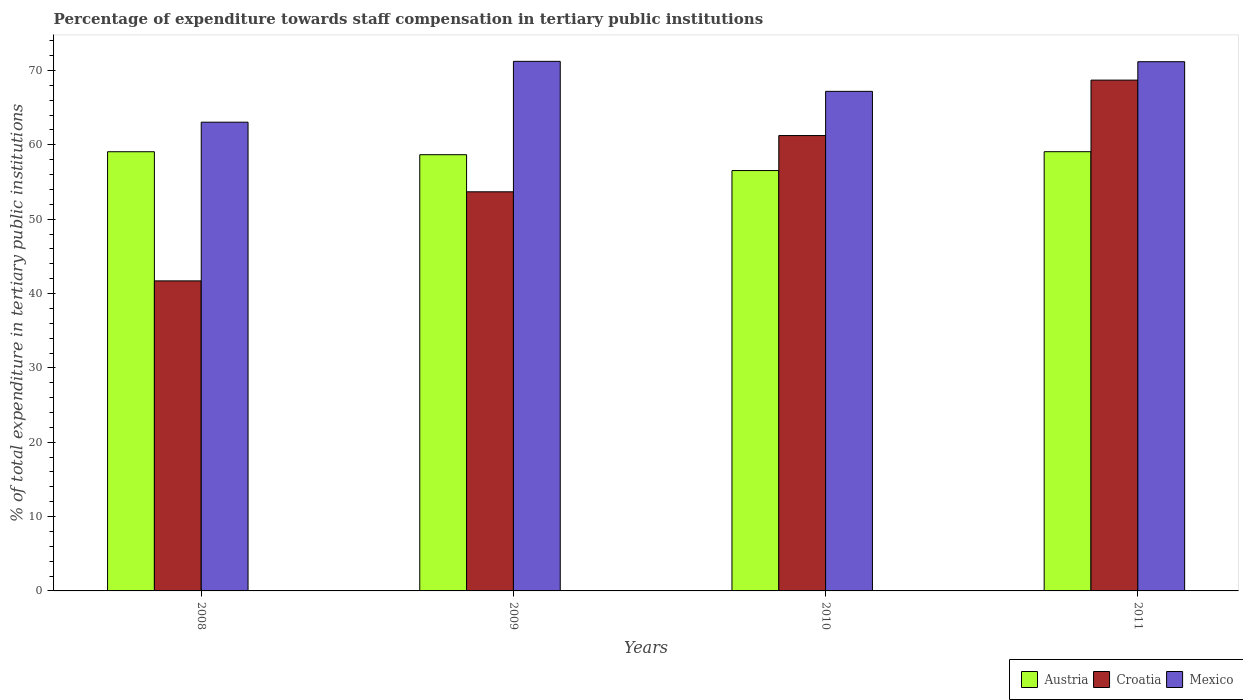How many groups of bars are there?
Your answer should be compact. 4. What is the percentage of expenditure towards staff compensation in Austria in 2008?
Keep it short and to the point. 59.08. Across all years, what is the maximum percentage of expenditure towards staff compensation in Mexico?
Provide a succinct answer. 71.23. Across all years, what is the minimum percentage of expenditure towards staff compensation in Austria?
Make the answer very short. 56.54. In which year was the percentage of expenditure towards staff compensation in Austria minimum?
Your answer should be compact. 2010. What is the total percentage of expenditure towards staff compensation in Mexico in the graph?
Offer a very short reply. 272.67. What is the difference between the percentage of expenditure towards staff compensation in Mexico in 2010 and that in 2011?
Offer a very short reply. -3.99. What is the difference between the percentage of expenditure towards staff compensation in Croatia in 2008 and the percentage of expenditure towards staff compensation in Austria in 2010?
Make the answer very short. -14.84. What is the average percentage of expenditure towards staff compensation in Croatia per year?
Your answer should be very brief. 56.34. In the year 2009, what is the difference between the percentage of expenditure towards staff compensation in Croatia and percentage of expenditure towards staff compensation in Austria?
Ensure brevity in your answer.  -4.99. What is the ratio of the percentage of expenditure towards staff compensation in Mexico in 2008 to that in 2009?
Your response must be concise. 0.89. Is the percentage of expenditure towards staff compensation in Austria in 2008 less than that in 2009?
Your response must be concise. No. What is the difference between the highest and the second highest percentage of expenditure towards staff compensation in Mexico?
Keep it short and to the point. 0.05. What is the difference between the highest and the lowest percentage of expenditure towards staff compensation in Croatia?
Provide a short and direct response. 27.01. What does the 3rd bar from the left in 2009 represents?
Keep it short and to the point. Mexico. What does the 2nd bar from the right in 2008 represents?
Offer a very short reply. Croatia. How many bars are there?
Provide a succinct answer. 12. Are all the bars in the graph horizontal?
Ensure brevity in your answer.  No. How many years are there in the graph?
Provide a short and direct response. 4. Are the values on the major ticks of Y-axis written in scientific E-notation?
Offer a terse response. No. Does the graph contain grids?
Provide a succinct answer. No. Where does the legend appear in the graph?
Offer a very short reply. Bottom right. How many legend labels are there?
Ensure brevity in your answer.  3. How are the legend labels stacked?
Ensure brevity in your answer.  Horizontal. What is the title of the graph?
Provide a succinct answer. Percentage of expenditure towards staff compensation in tertiary public institutions. Does "Tanzania" appear as one of the legend labels in the graph?
Ensure brevity in your answer.  No. What is the label or title of the X-axis?
Offer a very short reply. Years. What is the label or title of the Y-axis?
Offer a terse response. % of total expenditure in tertiary public institutions. What is the % of total expenditure in tertiary public institutions in Austria in 2008?
Provide a succinct answer. 59.08. What is the % of total expenditure in tertiary public institutions in Croatia in 2008?
Make the answer very short. 41.7. What is the % of total expenditure in tertiary public institutions in Mexico in 2008?
Give a very brief answer. 63.05. What is the % of total expenditure in tertiary public institutions in Austria in 2009?
Offer a very short reply. 58.68. What is the % of total expenditure in tertiary public institutions of Croatia in 2009?
Make the answer very short. 53.69. What is the % of total expenditure in tertiary public institutions in Mexico in 2009?
Provide a succinct answer. 71.23. What is the % of total expenditure in tertiary public institutions in Austria in 2010?
Your response must be concise. 56.54. What is the % of total expenditure in tertiary public institutions in Croatia in 2010?
Your answer should be very brief. 61.25. What is the % of total expenditure in tertiary public institutions in Mexico in 2010?
Ensure brevity in your answer.  67.2. What is the % of total expenditure in tertiary public institutions of Austria in 2011?
Provide a succinct answer. 59.08. What is the % of total expenditure in tertiary public institutions in Croatia in 2011?
Provide a succinct answer. 68.71. What is the % of total expenditure in tertiary public institutions of Mexico in 2011?
Keep it short and to the point. 71.19. Across all years, what is the maximum % of total expenditure in tertiary public institutions of Austria?
Keep it short and to the point. 59.08. Across all years, what is the maximum % of total expenditure in tertiary public institutions in Croatia?
Provide a short and direct response. 68.71. Across all years, what is the maximum % of total expenditure in tertiary public institutions in Mexico?
Provide a short and direct response. 71.23. Across all years, what is the minimum % of total expenditure in tertiary public institutions of Austria?
Ensure brevity in your answer.  56.54. Across all years, what is the minimum % of total expenditure in tertiary public institutions of Croatia?
Your response must be concise. 41.7. Across all years, what is the minimum % of total expenditure in tertiary public institutions in Mexico?
Offer a very short reply. 63.05. What is the total % of total expenditure in tertiary public institutions in Austria in the graph?
Give a very brief answer. 233.38. What is the total % of total expenditure in tertiary public institutions of Croatia in the graph?
Keep it short and to the point. 225.35. What is the total % of total expenditure in tertiary public institutions in Mexico in the graph?
Provide a short and direct response. 272.67. What is the difference between the % of total expenditure in tertiary public institutions of Austria in 2008 and that in 2009?
Offer a terse response. 0.4. What is the difference between the % of total expenditure in tertiary public institutions in Croatia in 2008 and that in 2009?
Offer a very short reply. -11.98. What is the difference between the % of total expenditure in tertiary public institutions of Mexico in 2008 and that in 2009?
Keep it short and to the point. -8.18. What is the difference between the % of total expenditure in tertiary public institutions of Austria in 2008 and that in 2010?
Keep it short and to the point. 2.53. What is the difference between the % of total expenditure in tertiary public institutions of Croatia in 2008 and that in 2010?
Provide a succinct answer. -19.55. What is the difference between the % of total expenditure in tertiary public institutions in Mexico in 2008 and that in 2010?
Provide a short and direct response. -4.15. What is the difference between the % of total expenditure in tertiary public institutions of Austria in 2008 and that in 2011?
Ensure brevity in your answer.  -0. What is the difference between the % of total expenditure in tertiary public institutions in Croatia in 2008 and that in 2011?
Keep it short and to the point. -27.01. What is the difference between the % of total expenditure in tertiary public institutions in Mexico in 2008 and that in 2011?
Keep it short and to the point. -8.14. What is the difference between the % of total expenditure in tertiary public institutions in Austria in 2009 and that in 2010?
Keep it short and to the point. 2.13. What is the difference between the % of total expenditure in tertiary public institutions in Croatia in 2009 and that in 2010?
Ensure brevity in your answer.  -7.57. What is the difference between the % of total expenditure in tertiary public institutions in Mexico in 2009 and that in 2010?
Offer a very short reply. 4.04. What is the difference between the % of total expenditure in tertiary public institutions of Austria in 2009 and that in 2011?
Make the answer very short. -0.4. What is the difference between the % of total expenditure in tertiary public institutions of Croatia in 2009 and that in 2011?
Give a very brief answer. -15.02. What is the difference between the % of total expenditure in tertiary public institutions in Mexico in 2009 and that in 2011?
Your response must be concise. 0.05. What is the difference between the % of total expenditure in tertiary public institutions of Austria in 2010 and that in 2011?
Make the answer very short. -2.54. What is the difference between the % of total expenditure in tertiary public institutions of Croatia in 2010 and that in 2011?
Offer a very short reply. -7.46. What is the difference between the % of total expenditure in tertiary public institutions of Mexico in 2010 and that in 2011?
Offer a very short reply. -3.99. What is the difference between the % of total expenditure in tertiary public institutions of Austria in 2008 and the % of total expenditure in tertiary public institutions of Croatia in 2009?
Make the answer very short. 5.39. What is the difference between the % of total expenditure in tertiary public institutions of Austria in 2008 and the % of total expenditure in tertiary public institutions of Mexico in 2009?
Offer a very short reply. -12.16. What is the difference between the % of total expenditure in tertiary public institutions in Croatia in 2008 and the % of total expenditure in tertiary public institutions in Mexico in 2009?
Give a very brief answer. -29.53. What is the difference between the % of total expenditure in tertiary public institutions of Austria in 2008 and the % of total expenditure in tertiary public institutions of Croatia in 2010?
Give a very brief answer. -2.18. What is the difference between the % of total expenditure in tertiary public institutions in Austria in 2008 and the % of total expenditure in tertiary public institutions in Mexico in 2010?
Your answer should be compact. -8.12. What is the difference between the % of total expenditure in tertiary public institutions in Croatia in 2008 and the % of total expenditure in tertiary public institutions in Mexico in 2010?
Your answer should be very brief. -25.49. What is the difference between the % of total expenditure in tertiary public institutions of Austria in 2008 and the % of total expenditure in tertiary public institutions of Croatia in 2011?
Ensure brevity in your answer.  -9.63. What is the difference between the % of total expenditure in tertiary public institutions of Austria in 2008 and the % of total expenditure in tertiary public institutions of Mexico in 2011?
Ensure brevity in your answer.  -12.11. What is the difference between the % of total expenditure in tertiary public institutions in Croatia in 2008 and the % of total expenditure in tertiary public institutions in Mexico in 2011?
Make the answer very short. -29.48. What is the difference between the % of total expenditure in tertiary public institutions of Austria in 2009 and the % of total expenditure in tertiary public institutions of Croatia in 2010?
Offer a terse response. -2.58. What is the difference between the % of total expenditure in tertiary public institutions of Austria in 2009 and the % of total expenditure in tertiary public institutions of Mexico in 2010?
Your answer should be very brief. -8.52. What is the difference between the % of total expenditure in tertiary public institutions in Croatia in 2009 and the % of total expenditure in tertiary public institutions in Mexico in 2010?
Keep it short and to the point. -13.51. What is the difference between the % of total expenditure in tertiary public institutions of Austria in 2009 and the % of total expenditure in tertiary public institutions of Croatia in 2011?
Provide a succinct answer. -10.03. What is the difference between the % of total expenditure in tertiary public institutions in Austria in 2009 and the % of total expenditure in tertiary public institutions in Mexico in 2011?
Your answer should be very brief. -12.51. What is the difference between the % of total expenditure in tertiary public institutions in Croatia in 2009 and the % of total expenditure in tertiary public institutions in Mexico in 2011?
Your answer should be very brief. -17.5. What is the difference between the % of total expenditure in tertiary public institutions in Austria in 2010 and the % of total expenditure in tertiary public institutions in Croatia in 2011?
Your response must be concise. -12.17. What is the difference between the % of total expenditure in tertiary public institutions in Austria in 2010 and the % of total expenditure in tertiary public institutions in Mexico in 2011?
Offer a very short reply. -14.64. What is the difference between the % of total expenditure in tertiary public institutions of Croatia in 2010 and the % of total expenditure in tertiary public institutions of Mexico in 2011?
Your answer should be compact. -9.93. What is the average % of total expenditure in tertiary public institutions of Austria per year?
Provide a short and direct response. 58.34. What is the average % of total expenditure in tertiary public institutions of Croatia per year?
Give a very brief answer. 56.34. What is the average % of total expenditure in tertiary public institutions in Mexico per year?
Ensure brevity in your answer.  68.17. In the year 2008, what is the difference between the % of total expenditure in tertiary public institutions in Austria and % of total expenditure in tertiary public institutions in Croatia?
Your response must be concise. 17.37. In the year 2008, what is the difference between the % of total expenditure in tertiary public institutions of Austria and % of total expenditure in tertiary public institutions of Mexico?
Make the answer very short. -3.97. In the year 2008, what is the difference between the % of total expenditure in tertiary public institutions of Croatia and % of total expenditure in tertiary public institutions of Mexico?
Keep it short and to the point. -21.35. In the year 2009, what is the difference between the % of total expenditure in tertiary public institutions in Austria and % of total expenditure in tertiary public institutions in Croatia?
Provide a short and direct response. 4.99. In the year 2009, what is the difference between the % of total expenditure in tertiary public institutions in Austria and % of total expenditure in tertiary public institutions in Mexico?
Keep it short and to the point. -12.56. In the year 2009, what is the difference between the % of total expenditure in tertiary public institutions of Croatia and % of total expenditure in tertiary public institutions of Mexico?
Keep it short and to the point. -17.55. In the year 2010, what is the difference between the % of total expenditure in tertiary public institutions of Austria and % of total expenditure in tertiary public institutions of Croatia?
Your answer should be very brief. -4.71. In the year 2010, what is the difference between the % of total expenditure in tertiary public institutions of Austria and % of total expenditure in tertiary public institutions of Mexico?
Offer a very short reply. -10.65. In the year 2010, what is the difference between the % of total expenditure in tertiary public institutions of Croatia and % of total expenditure in tertiary public institutions of Mexico?
Provide a succinct answer. -5.94. In the year 2011, what is the difference between the % of total expenditure in tertiary public institutions in Austria and % of total expenditure in tertiary public institutions in Croatia?
Offer a very short reply. -9.63. In the year 2011, what is the difference between the % of total expenditure in tertiary public institutions of Austria and % of total expenditure in tertiary public institutions of Mexico?
Offer a terse response. -12.1. In the year 2011, what is the difference between the % of total expenditure in tertiary public institutions in Croatia and % of total expenditure in tertiary public institutions in Mexico?
Give a very brief answer. -2.48. What is the ratio of the % of total expenditure in tertiary public institutions in Austria in 2008 to that in 2009?
Your answer should be compact. 1.01. What is the ratio of the % of total expenditure in tertiary public institutions in Croatia in 2008 to that in 2009?
Your answer should be compact. 0.78. What is the ratio of the % of total expenditure in tertiary public institutions of Mexico in 2008 to that in 2009?
Your answer should be compact. 0.89. What is the ratio of the % of total expenditure in tertiary public institutions in Austria in 2008 to that in 2010?
Offer a terse response. 1.04. What is the ratio of the % of total expenditure in tertiary public institutions in Croatia in 2008 to that in 2010?
Keep it short and to the point. 0.68. What is the ratio of the % of total expenditure in tertiary public institutions of Mexico in 2008 to that in 2010?
Give a very brief answer. 0.94. What is the ratio of the % of total expenditure in tertiary public institutions of Austria in 2008 to that in 2011?
Provide a short and direct response. 1. What is the ratio of the % of total expenditure in tertiary public institutions in Croatia in 2008 to that in 2011?
Provide a succinct answer. 0.61. What is the ratio of the % of total expenditure in tertiary public institutions in Mexico in 2008 to that in 2011?
Give a very brief answer. 0.89. What is the ratio of the % of total expenditure in tertiary public institutions of Austria in 2009 to that in 2010?
Provide a short and direct response. 1.04. What is the ratio of the % of total expenditure in tertiary public institutions in Croatia in 2009 to that in 2010?
Provide a succinct answer. 0.88. What is the ratio of the % of total expenditure in tertiary public institutions in Mexico in 2009 to that in 2010?
Provide a short and direct response. 1.06. What is the ratio of the % of total expenditure in tertiary public institutions in Croatia in 2009 to that in 2011?
Ensure brevity in your answer.  0.78. What is the ratio of the % of total expenditure in tertiary public institutions in Austria in 2010 to that in 2011?
Your response must be concise. 0.96. What is the ratio of the % of total expenditure in tertiary public institutions in Croatia in 2010 to that in 2011?
Provide a succinct answer. 0.89. What is the ratio of the % of total expenditure in tertiary public institutions of Mexico in 2010 to that in 2011?
Provide a succinct answer. 0.94. What is the difference between the highest and the second highest % of total expenditure in tertiary public institutions of Austria?
Give a very brief answer. 0. What is the difference between the highest and the second highest % of total expenditure in tertiary public institutions in Croatia?
Your answer should be compact. 7.46. What is the difference between the highest and the second highest % of total expenditure in tertiary public institutions in Mexico?
Provide a succinct answer. 0.05. What is the difference between the highest and the lowest % of total expenditure in tertiary public institutions in Austria?
Keep it short and to the point. 2.54. What is the difference between the highest and the lowest % of total expenditure in tertiary public institutions of Croatia?
Your response must be concise. 27.01. What is the difference between the highest and the lowest % of total expenditure in tertiary public institutions in Mexico?
Offer a terse response. 8.18. 